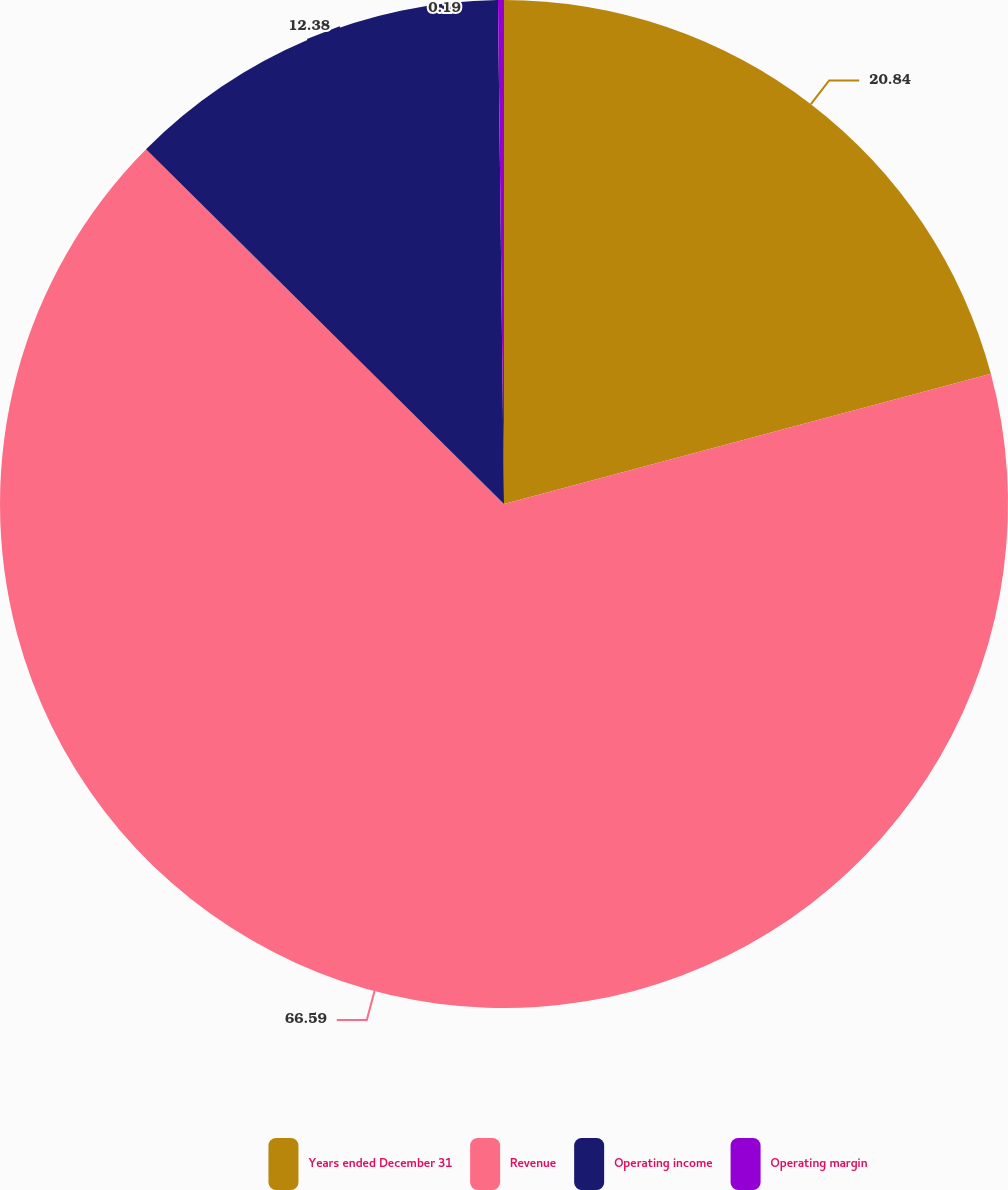Convert chart. <chart><loc_0><loc_0><loc_500><loc_500><pie_chart><fcel>Years ended December 31<fcel>Revenue<fcel>Operating income<fcel>Operating margin<nl><fcel>20.84%<fcel>66.59%<fcel>12.38%<fcel>0.19%<nl></chart> 